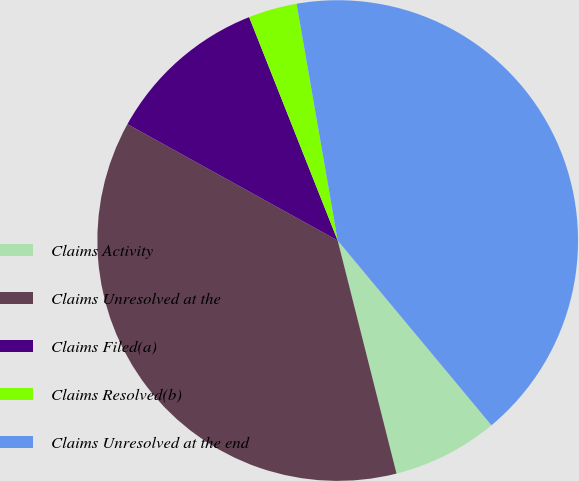<chart> <loc_0><loc_0><loc_500><loc_500><pie_chart><fcel>Claims Activity<fcel>Claims Unresolved at the<fcel>Claims Filed(a)<fcel>Claims Resolved(b)<fcel>Claims Unresolved at the end<nl><fcel>7.11%<fcel>36.98%<fcel>10.95%<fcel>3.27%<fcel>41.69%<nl></chart> 